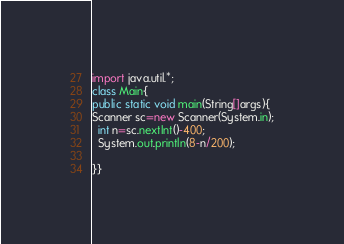<code> <loc_0><loc_0><loc_500><loc_500><_Java_>import java.util.*;
class Main{
public static void main(String[]args){
Scanner sc=new Scanner(System.in);
  int n=sc.nextInt()-400;
  System.out.println(8-n/200);

}}</code> 